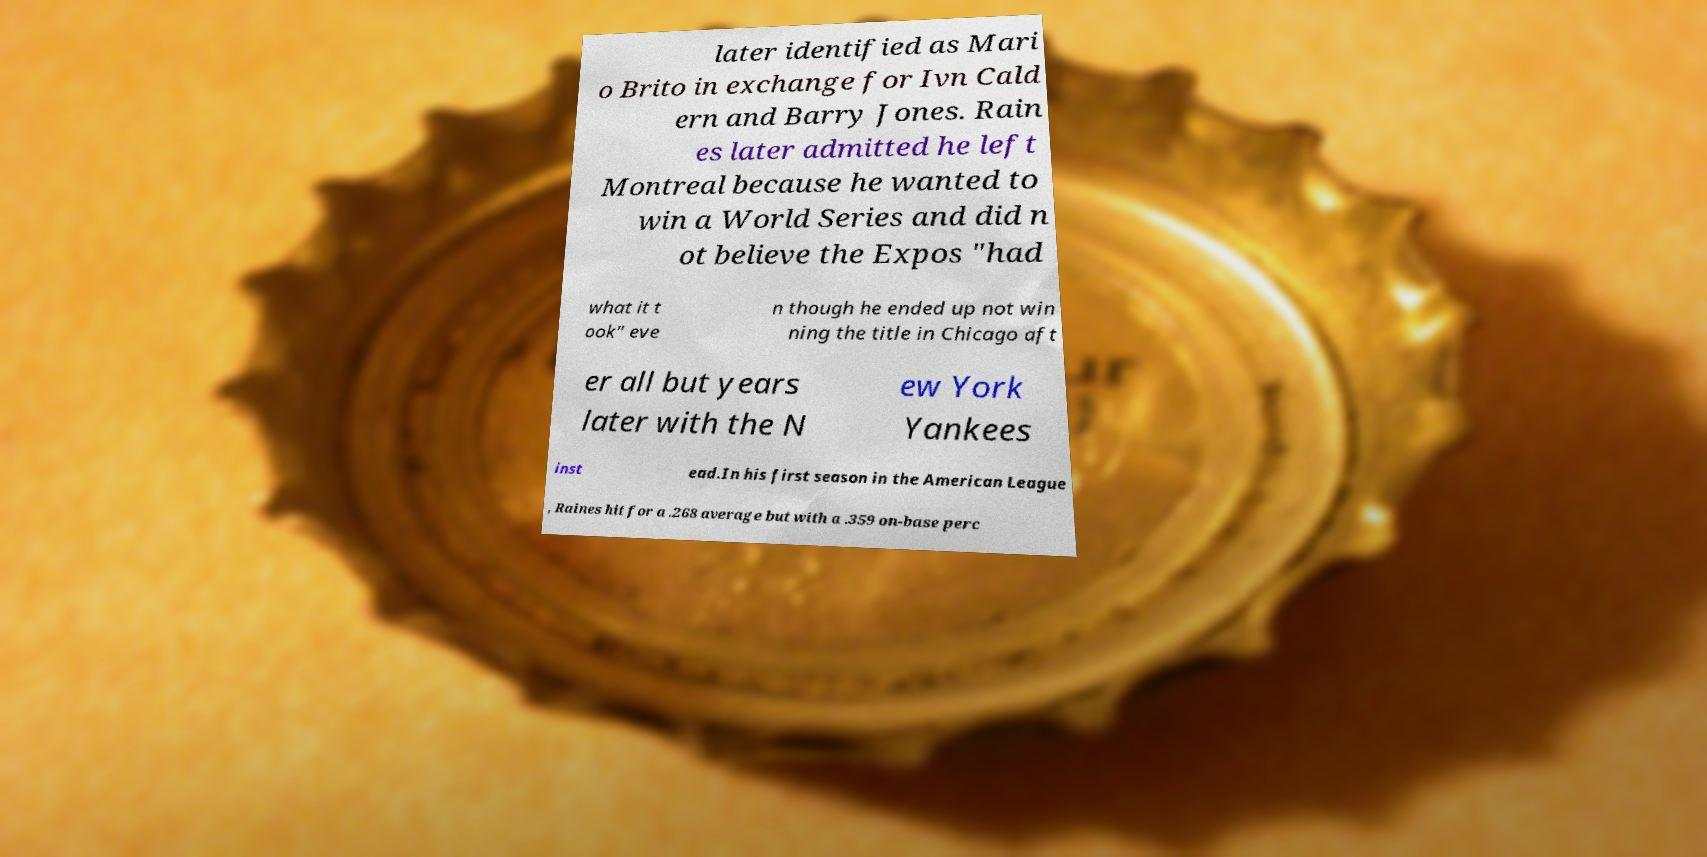What messages or text are displayed in this image? I need them in a readable, typed format. later identified as Mari o Brito in exchange for Ivn Cald ern and Barry Jones. Rain es later admitted he left Montreal because he wanted to win a World Series and did n ot believe the Expos "had what it t ook" eve n though he ended up not win ning the title in Chicago aft er all but years later with the N ew York Yankees inst ead.In his first season in the American League , Raines hit for a .268 average but with a .359 on-base perc 